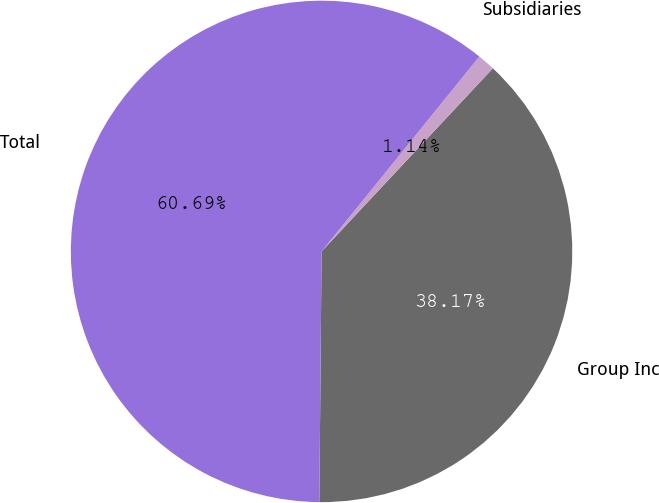Convert chart. <chart><loc_0><loc_0><loc_500><loc_500><pie_chart><fcel>Group Inc<fcel>Subsidiaries<fcel>Total<nl><fcel>38.17%<fcel>1.14%<fcel>60.69%<nl></chart> 